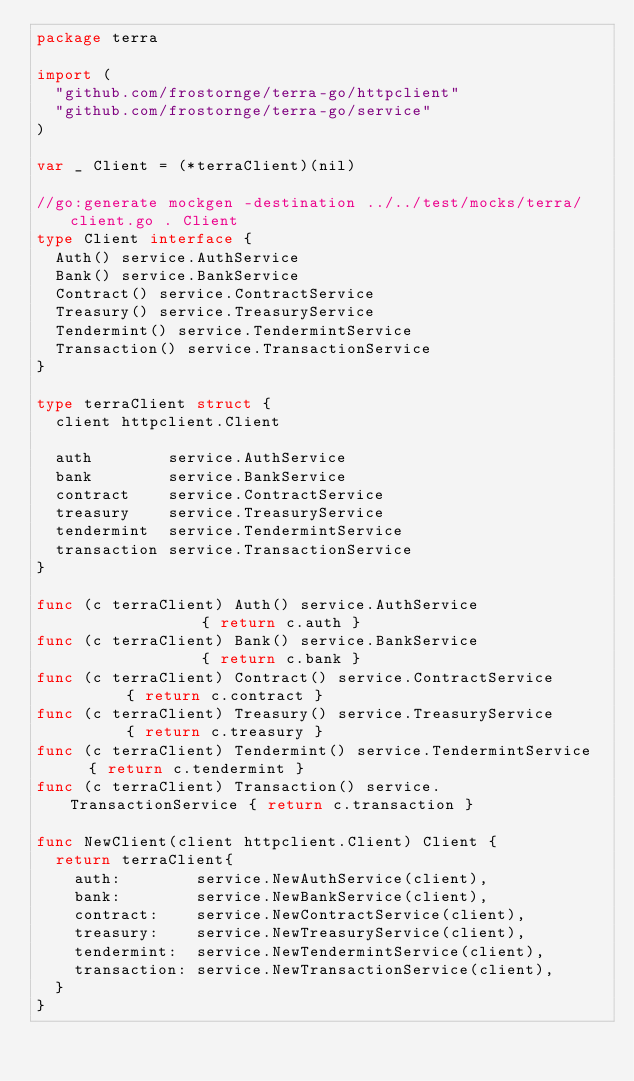<code> <loc_0><loc_0><loc_500><loc_500><_Go_>package terra

import (
	"github.com/frostornge/terra-go/httpclient"
	"github.com/frostornge/terra-go/service"
)

var _ Client = (*terraClient)(nil)

//go:generate mockgen -destination ../../test/mocks/terra/client.go . Client
type Client interface {
	Auth() service.AuthService
	Bank() service.BankService
	Contract() service.ContractService
	Treasury() service.TreasuryService
	Tendermint() service.TendermintService
	Transaction() service.TransactionService
}

type terraClient struct {
	client httpclient.Client

	auth        service.AuthService
	bank        service.BankService
	contract    service.ContractService
	treasury    service.TreasuryService
	tendermint  service.TendermintService
	transaction service.TransactionService
}

func (c terraClient) Auth() service.AuthService               { return c.auth }
func (c terraClient) Bank() service.BankService               { return c.bank }
func (c terraClient) Contract() service.ContractService       { return c.contract }
func (c terraClient) Treasury() service.TreasuryService       { return c.treasury }
func (c terraClient) Tendermint() service.TendermintService   { return c.tendermint }
func (c terraClient) Transaction() service.TransactionService { return c.transaction }

func NewClient(client httpclient.Client) Client {
	return terraClient{
		auth:        service.NewAuthService(client),
		bank:        service.NewBankService(client),
		contract:    service.NewContractService(client),
		treasury:    service.NewTreasuryService(client),
		tendermint:  service.NewTendermintService(client),
		transaction: service.NewTransactionService(client),
	}
}
</code> 